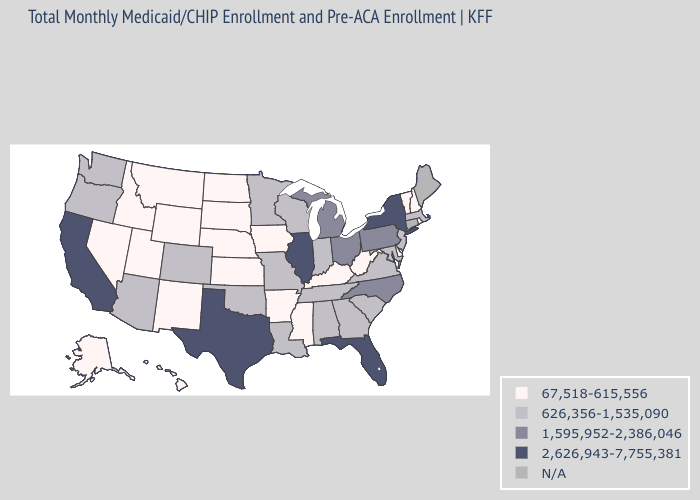What is the highest value in the South ?
Write a very short answer. 2,626,943-7,755,381. Name the states that have a value in the range 1,595,952-2,386,046?
Be succinct. Michigan, North Carolina, Ohio, Pennsylvania. What is the value of North Dakota?
Short answer required. 67,518-615,556. What is the lowest value in states that border Nevada?
Keep it brief. 67,518-615,556. What is the value of Kentucky?
Be succinct. 67,518-615,556. Which states have the lowest value in the South?
Keep it brief. Arkansas, Delaware, Kentucky, Mississippi, West Virginia. Name the states that have a value in the range 626,356-1,535,090?
Answer briefly. Alabama, Arizona, Colorado, Georgia, Indiana, Louisiana, Maryland, Massachusetts, Minnesota, Missouri, New Jersey, Oklahoma, Oregon, South Carolina, Tennessee, Virginia, Washington, Wisconsin. What is the value of Utah?
Give a very brief answer. 67,518-615,556. Name the states that have a value in the range N/A?
Quick response, please. Connecticut, Maine. What is the lowest value in the USA?
Be succinct. 67,518-615,556. Does New York have the highest value in the USA?
Concise answer only. Yes. What is the highest value in the USA?
Write a very short answer. 2,626,943-7,755,381. What is the value of Hawaii?
Be succinct. 67,518-615,556. What is the value of Michigan?
Answer briefly. 1,595,952-2,386,046. 